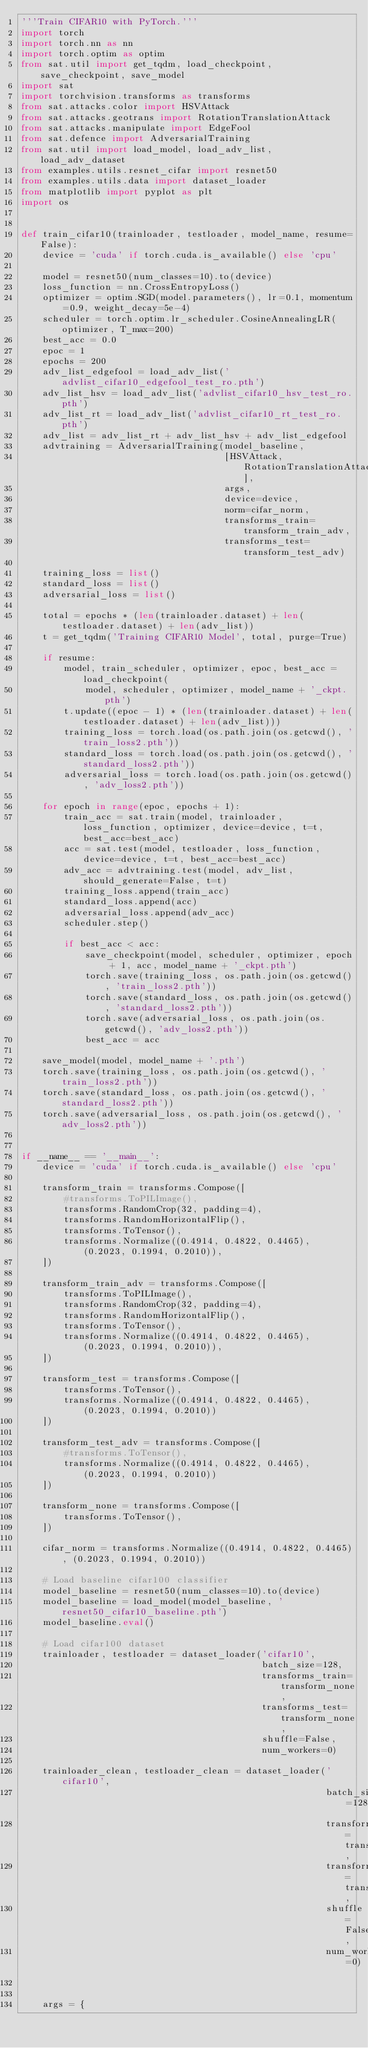<code> <loc_0><loc_0><loc_500><loc_500><_Python_>'''Train CIFAR10 with PyTorch.'''
import torch
import torch.nn as nn
import torch.optim as optim
from sat.util import get_tqdm, load_checkpoint, save_checkpoint, save_model
import sat
import torchvision.transforms as transforms
from sat.attacks.color import HSVAttack
from sat.attacks.geotrans import RotationTranslationAttack
from sat.attacks.manipulate import EdgeFool
from sat.defence import AdversarialTraining
from sat.util import load_model, load_adv_list, load_adv_dataset
from examples.utils.resnet_cifar import resnet50
from examples.utils.data import dataset_loader
from matplotlib import pyplot as plt
import os


def train_cifar10(trainloader, testloader, model_name, resume=False):
    device = 'cuda' if torch.cuda.is_available() else 'cpu'

    model = resnet50(num_classes=10).to(device)
    loss_function = nn.CrossEntropyLoss()
    optimizer = optim.SGD(model.parameters(), lr=0.1, momentum=0.9, weight_decay=5e-4)
    scheduler = torch.optim.lr_scheduler.CosineAnnealingLR(optimizer, T_max=200)
    best_acc = 0.0
    epoc = 1
    epochs = 200
    adv_list_edgefool = load_adv_list('advlist_cifar10_edgefool_test_ro.pth')
    adv_list_hsv = load_adv_list('advlist_cifar10_hsv_test_ro.pth')
    adv_list_rt = load_adv_list('advlist_cifar10_rt_test_ro.pth')
    adv_list = adv_list_rt + adv_list_hsv + adv_list_edgefool
    advtraining = AdversarialTraining(model_baseline,
                                      [HSVAttack, RotationTranslationAttack],
                                      args,
                                      device=device,
                                      norm=cifar_norm,
                                      transforms_train=transform_train_adv,
                                      transforms_test=transform_test_adv)

    training_loss = list()
    standard_loss = list()
    adversarial_loss = list()

    total = epochs * (len(trainloader.dataset) + len(testloader.dataset) + len(adv_list))
    t = get_tqdm('Training CIFAR10 Model', total, purge=True)

    if resume:
        model, train_scheduler, optimizer, epoc, best_acc = load_checkpoint(
            model, scheduler, optimizer, model_name + '_ckpt.pth')
        t.update((epoc - 1) * (len(trainloader.dataset) + len(testloader.dataset) + len(adv_list)))
        training_loss = torch.load(os.path.join(os.getcwd(), 'train_loss2.pth'))
        standard_loss = torch.load(os.path.join(os.getcwd(), 'standard_loss2.pth'))
        adversarial_loss = torch.load(os.path.join(os.getcwd(), 'adv_loss2.pth'))

    for epoch in range(epoc, epochs + 1):
        train_acc = sat.train(model, trainloader, loss_function, optimizer, device=device, t=t, best_acc=best_acc)
        acc = sat.test(model, testloader, loss_function, device=device, t=t, best_acc=best_acc)
        adv_acc = advtraining.test(model, adv_list, should_generate=False, t=t)
        training_loss.append(train_acc)
        standard_loss.append(acc)
        adversarial_loss.append(adv_acc)
        scheduler.step()

        if best_acc < acc:
            save_checkpoint(model, scheduler, optimizer, epoch + 1, acc, model_name + '_ckpt.pth')
            torch.save(training_loss, os.path.join(os.getcwd(), 'train_loss2.pth'))
            torch.save(standard_loss, os.path.join(os.getcwd(), 'standard_loss2.pth'))
            torch.save(adversarial_loss, os.path.join(os.getcwd(), 'adv_loss2.pth'))
            best_acc = acc

    save_model(model, model_name + '.pth')
    torch.save(training_loss, os.path.join(os.getcwd(), 'train_loss2.pth'))
    torch.save(standard_loss, os.path.join(os.getcwd(), 'standard_loss2.pth'))
    torch.save(adversarial_loss, os.path.join(os.getcwd(), 'adv_loss2.pth'))


if __name__ == '__main__':
    device = 'cuda' if torch.cuda.is_available() else 'cpu'

    transform_train = transforms.Compose([
        #transforms.ToPILImage(),
        transforms.RandomCrop(32, padding=4),
        transforms.RandomHorizontalFlip(),
        transforms.ToTensor(),
        transforms.Normalize((0.4914, 0.4822, 0.4465), (0.2023, 0.1994, 0.2010)),
    ])

    transform_train_adv = transforms.Compose([
        transforms.ToPILImage(),
        transforms.RandomCrop(32, padding=4),
        transforms.RandomHorizontalFlip(),
        transforms.ToTensor(),
        transforms.Normalize((0.4914, 0.4822, 0.4465), (0.2023, 0.1994, 0.2010)),
    ])

    transform_test = transforms.Compose([
        transforms.ToTensor(),
        transforms.Normalize((0.4914, 0.4822, 0.4465), (0.2023, 0.1994, 0.2010))
    ])

    transform_test_adv = transforms.Compose([
        #transforms.ToTensor(),
        transforms.Normalize((0.4914, 0.4822, 0.4465), (0.2023, 0.1994, 0.2010))
    ])

    transform_none = transforms.Compose([
        transforms.ToTensor(),
    ])

    cifar_norm = transforms.Normalize((0.4914, 0.4822, 0.4465), (0.2023, 0.1994, 0.2010))

    # Load baseline cifar100 classifier
    model_baseline = resnet50(num_classes=10).to(device)
    model_baseline = load_model(model_baseline, 'resnet50_cifar10_baseline.pth')
    model_baseline.eval()

    # Load cifar100 dataset
    trainloader, testloader = dataset_loader('cifar10',
                                             batch_size=128,
                                             transforms_train=transform_none,
                                             transforms_test=transform_none,
                                             shuffle=False,
                                             num_workers=0)

    trainloader_clean, testloader_clean = dataset_loader('cifar10',
                                                         batch_size=128,
                                                         transforms_train=transform_train,
                                                         transforms_test=transform_test,
                                                         shuffle=False,
                                                         num_workers=0)


    args = {</code> 